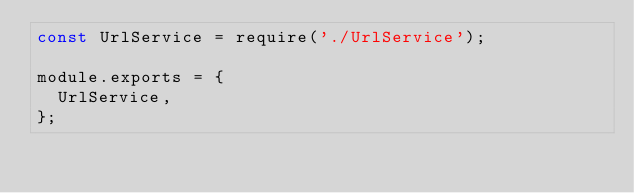<code> <loc_0><loc_0><loc_500><loc_500><_JavaScript_>const UrlService = require('./UrlService');

module.exports = {
  UrlService,
};
</code> 